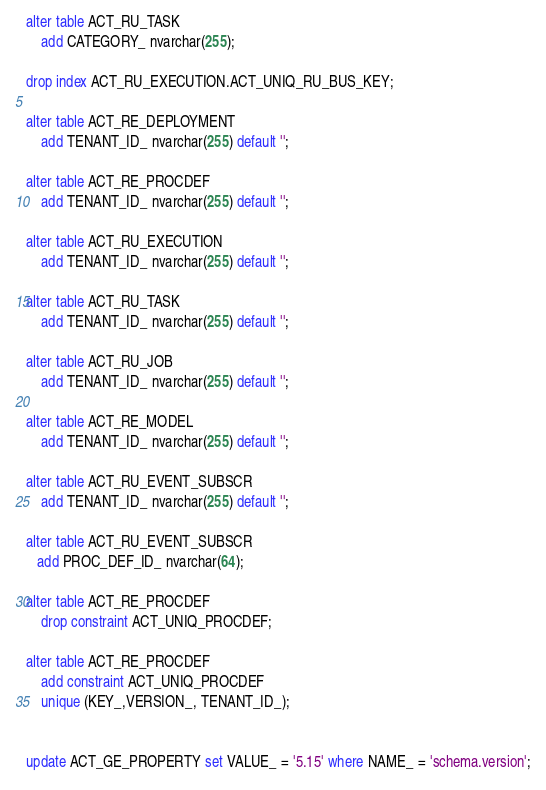<code> <loc_0><loc_0><loc_500><loc_500><_SQL_>alter table ACT_RU_TASK
    add CATEGORY_ nvarchar(255);

drop index ACT_RU_EXECUTION.ACT_UNIQ_RU_BUS_KEY;

alter table ACT_RE_DEPLOYMENT
    add TENANT_ID_ nvarchar(255) default '';

alter table ACT_RE_PROCDEF
    add TENANT_ID_ nvarchar(255) default '';

alter table ACT_RU_EXECUTION
    add TENANT_ID_ nvarchar(255) default '';

alter table ACT_RU_TASK
    add TENANT_ID_ nvarchar(255) default '';

alter table ACT_RU_JOB
    add TENANT_ID_ nvarchar(255) default '';

alter table ACT_RE_MODEL
    add TENANT_ID_ nvarchar(255) default '';

alter table ACT_RU_EVENT_SUBSCR
    add TENANT_ID_ nvarchar(255) default '';

alter table ACT_RU_EVENT_SUBSCR
   add PROC_DEF_ID_ nvarchar(64);

alter table ACT_RE_PROCDEF
    drop constraint ACT_UNIQ_PROCDEF;

alter table ACT_RE_PROCDEF
    add constraint ACT_UNIQ_PROCDEF
    unique (KEY_,VERSION_, TENANT_ID_);


update ACT_GE_PROPERTY set VALUE_ = '5.15' where NAME_ = 'schema.version';
</code> 